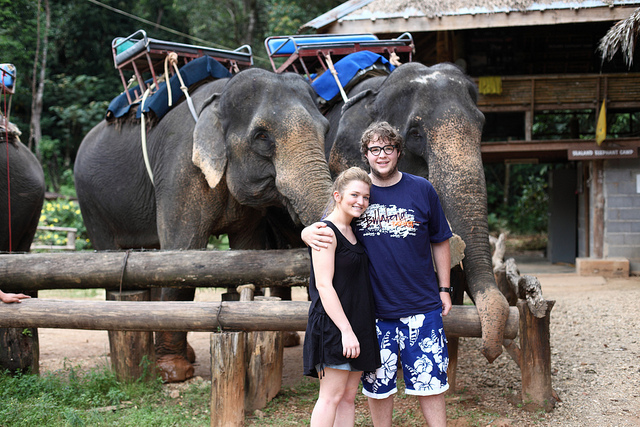How many elephants can be seen? In the image, there are three elephants visible. They appear to be adult elephants, and they are equipped with harnesses and seats for carrying riders, which suggests that they might be part of an elephant riding operation. 